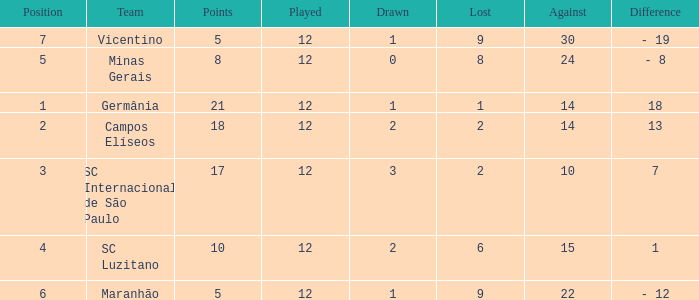What is the sum of drawn that has a played more than 12? 0.0. 